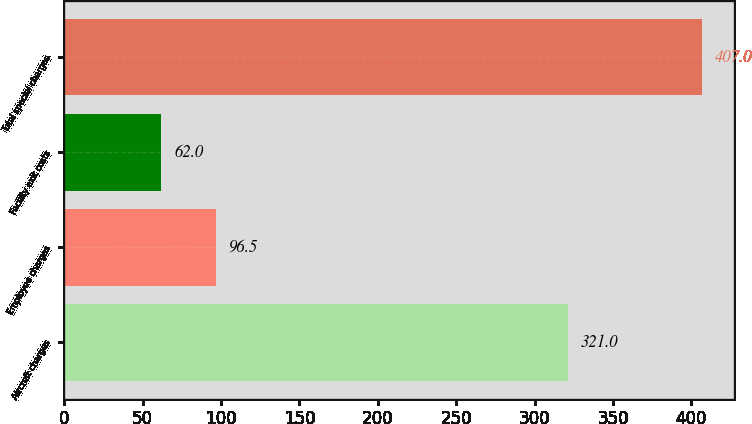<chart> <loc_0><loc_0><loc_500><loc_500><bar_chart><fcel>Aircraft charges<fcel>Employee charges<fcel>Facility exit costs<fcel>Total special charges<nl><fcel>321<fcel>96.5<fcel>62<fcel>407<nl></chart> 